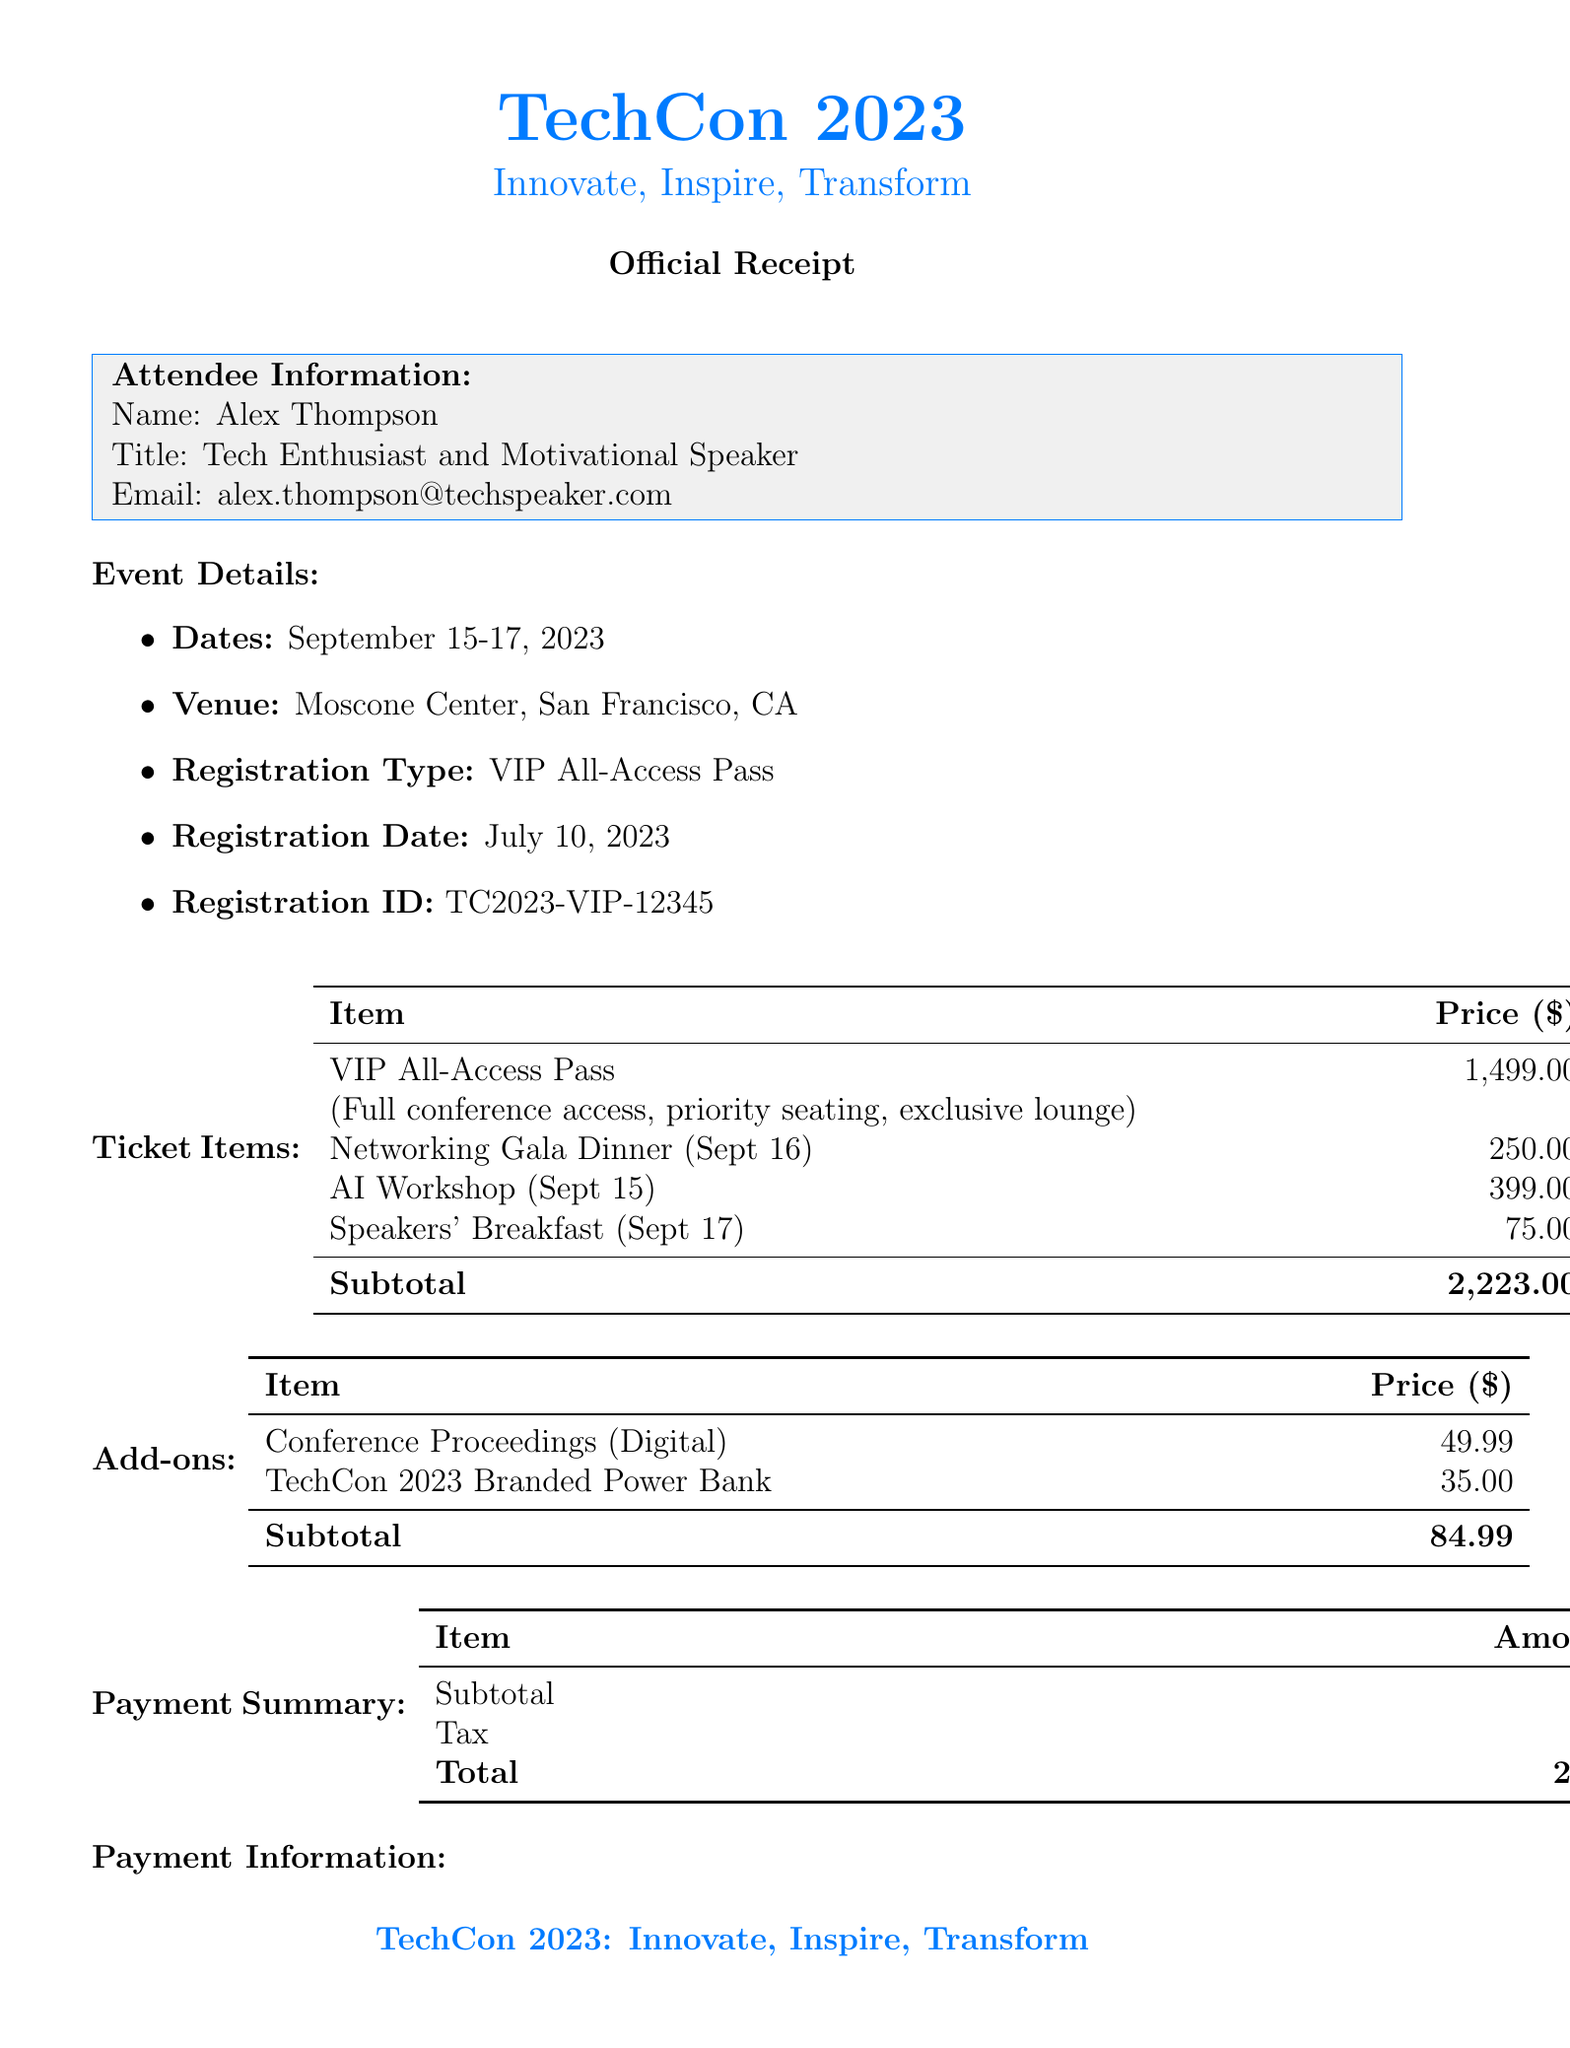What is the name of the conference? The name of the conference is listed in the document's title section.
Answer: TechCon 2023: Innovate, Inspire, Transform What are the dates of the conference? The dates of the conference are provided in the event details section of the document.
Answer: September 15-17, 2023 Who is the attendee? The attendee's name is included in the attendee information section.
Answer: Alex Thompson What type of registration was purchased? The type of registration is specified in the event details section of the document.
Answer: VIP All-Access Pass What is the subtotal amount for ticket items? The subtotal for ticket items is detailed in the payment summary table of the document.
Answer: 2,307.99 What is the price of the Networking Gala Dinner? The price for the Networking Gala Dinner is found in the ticket items section of the document.
Answer: 250.00 When is the keynote speech scheduled? The schedule for the keynote speech can be found in the additional information section of the document.
Answer: Sept 16, 2:00 PM - 3:30 PM What is the refund policy? The refund policy is stated in the additional information section.
Answer: 50% refund available until August 15, 2023 What add-on item has the lowest price? The lowest priced add-on item is mentioned in the add-ons section of the document.
Answer: TechCon 2023 Branded Power Bank 